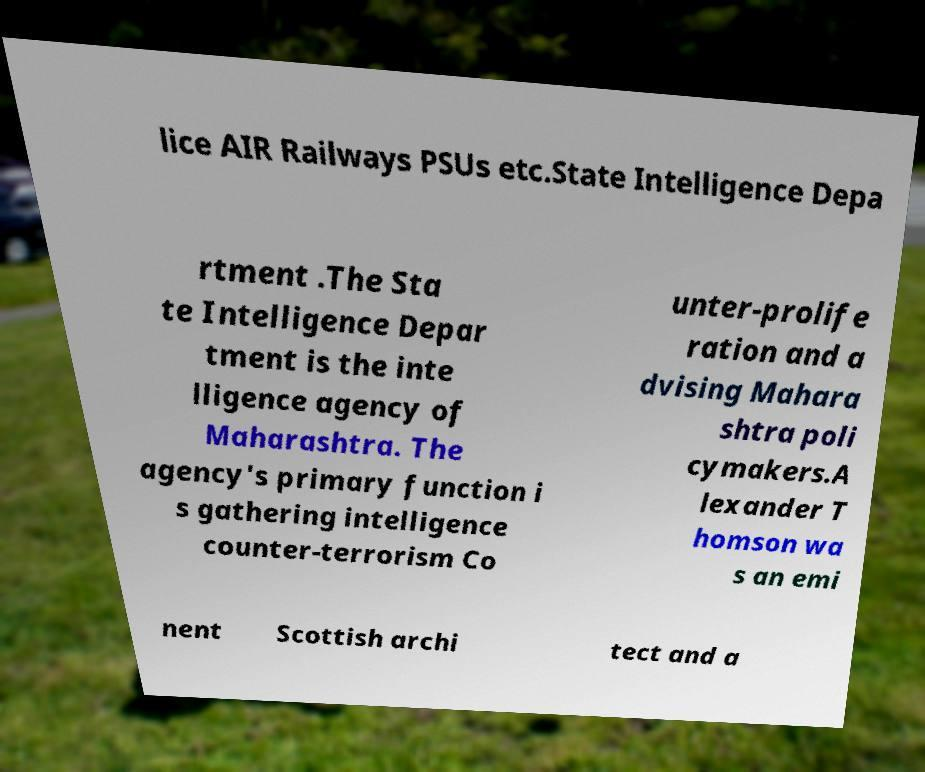There's text embedded in this image that I need extracted. Can you transcribe it verbatim? lice AIR Railways PSUs etc.State Intelligence Depa rtment .The Sta te Intelligence Depar tment is the inte lligence agency of Maharashtra. The agency's primary function i s gathering intelligence counter-terrorism Co unter-prolife ration and a dvising Mahara shtra poli cymakers.A lexander T homson wa s an emi nent Scottish archi tect and a 